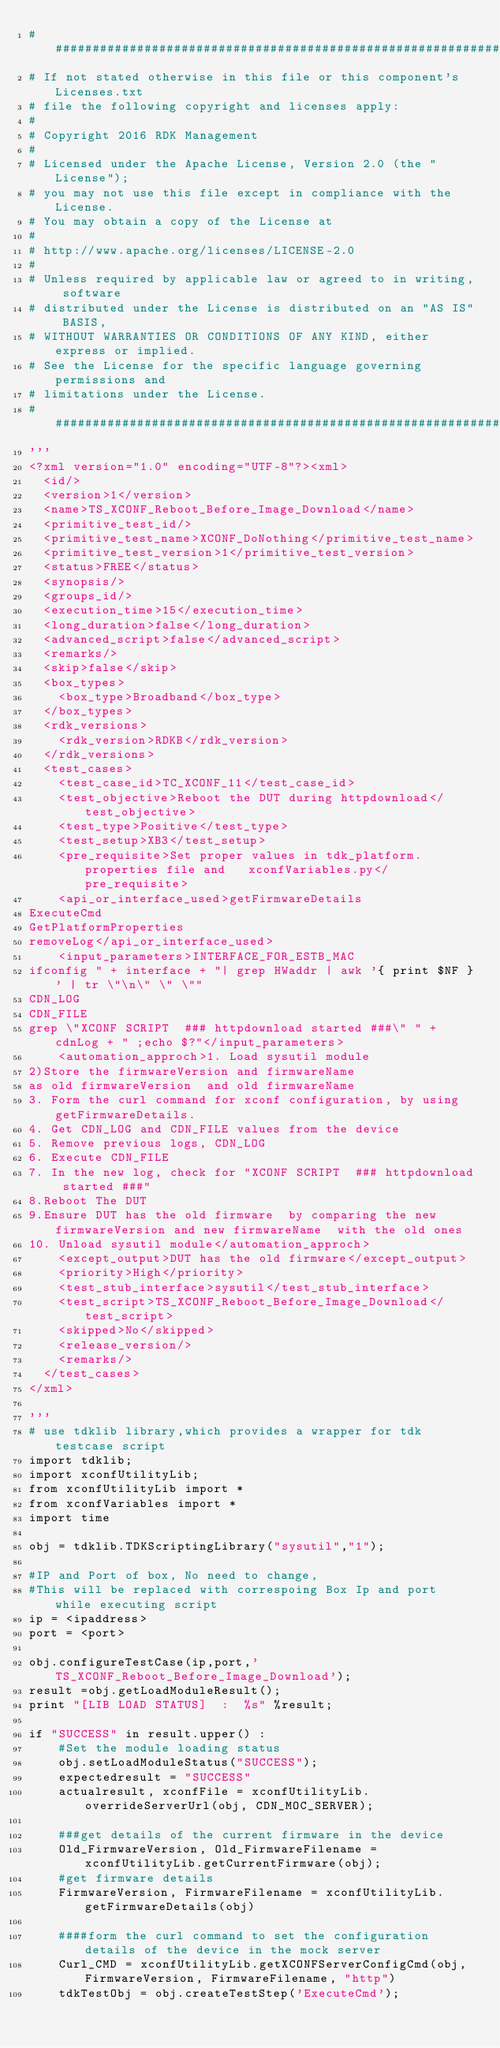Convert code to text. <code><loc_0><loc_0><loc_500><loc_500><_Python_>##########################################################################
# If not stated otherwise in this file or this component's Licenses.txt
# file the following copyright and licenses apply:
#
# Copyright 2016 RDK Management
#
# Licensed under the Apache License, Version 2.0 (the "License");
# you may not use this file except in compliance with the License.
# You may obtain a copy of the License at
#
# http://www.apache.org/licenses/LICENSE-2.0
#
# Unless required by applicable law or agreed to in writing, software
# distributed under the License is distributed on an "AS IS" BASIS,
# WITHOUT WARRANTIES OR CONDITIONS OF ANY KIND, either express or implied.
# See the License for the specific language governing permissions and
# limitations under the License.
##########################################################################
'''
<?xml version="1.0" encoding="UTF-8"?><xml>
  <id/>
  <version>1</version>
  <name>TS_XCONF_Reboot_Before_Image_Download</name>
  <primitive_test_id/>
  <primitive_test_name>XCONF_DoNothing</primitive_test_name>
  <primitive_test_version>1</primitive_test_version>
  <status>FREE</status>
  <synopsis/>
  <groups_id/>
  <execution_time>15</execution_time>
  <long_duration>false</long_duration>
  <advanced_script>false</advanced_script>
  <remarks/>
  <skip>false</skip>
  <box_types>
    <box_type>Broadband</box_type>
  </box_types>
  <rdk_versions>
    <rdk_version>RDKB</rdk_version>
  </rdk_versions>
  <test_cases>
    <test_case_id>TC_XCONF_11</test_case_id>
    <test_objective>Reboot the DUT during httpdownload</test_objective>
    <test_type>Positive</test_type>
    <test_setup>XB3</test_setup>
    <pre_requisite>Set proper values in tdk_platform.properties file and   xconfVariables.py</pre_requisite>
    <api_or_interface_used>getFirmwareDetails
ExecuteCmd
GetPlatformProperties
removeLog</api_or_interface_used>
    <input_parameters>INTERFACE_FOR_ESTB_MAC
ifconfig " + interface + "| grep HWaddr | awk '{ print $NF }' | tr \"\n\" \" \""
CDN_LOG
CDN_FILE
grep \"XCONF SCRIPT  ### httpdownload started ###\" " + cdnLog + " ;echo $?"</input_parameters>
    <automation_approch>1. Load sysutil module
2)Store the firmwareVersion and firmwareName 
as old firmwareVersion  and old firmwareName
3. Form the curl command for xconf configuration, by using getFirmwareDetails.
4. Get CDN_LOG and CDN_FILE values from the device
5. Remove previous logs, CDN_LOG
6. Execute CDN_FILE
7. In the new log, check for "XCONF SCRIPT  ### httpdownload started ###"
8.Reboot The DUT
9.Ensure DUT has the old firmware  by comparing the new firmwareVersion and new firmwareName  with the old ones
10. Unload sysutil module</automation_approch>
    <except_output>DUT has the old firmware</except_output>
    <priority>High</priority>
    <test_stub_interface>sysutil</test_stub_interface>
    <test_script>TS_XCONF_Reboot_Before_Image_Download</test_script>
    <skipped>No</skipped>
    <release_version/>
    <remarks/>
  </test_cases>
</xml>

'''
# use tdklib library,which provides a wrapper for tdk testcase script
import tdklib;
import xconfUtilityLib;
from xconfUtilityLib import *
from xconfVariables import *
import time

obj = tdklib.TDKScriptingLibrary("sysutil","1");

#IP and Port of box, No need to change,
#This will be replaced with correspoing Box Ip and port while executing script
ip = <ipaddress>
port = <port>

obj.configureTestCase(ip,port,'TS_XCONF_Reboot_Before_Image_Download');
result =obj.getLoadModuleResult();
print "[LIB LOAD STATUS]  :  %s" %result;

if "SUCCESS" in result.upper() :
    #Set the module loading status
    obj.setLoadModuleStatus("SUCCESS");
    expectedresult = "SUCCESS"
    actualresult, xconfFile = xconfUtilityLib.overrideServerUrl(obj, CDN_MOC_SERVER);

    ###get details of the current firmware in the device
    Old_FirmwareVersion, Old_FirmwareFilename = xconfUtilityLib.getCurrentFirmware(obj);
    #get firmware details
    FirmwareVersion, FirmwareFilename = xconfUtilityLib.getFirmwareDetails(obj)

    ####form the curl command to set the configuration details of the device in the mock server
    Curl_CMD = xconfUtilityLib.getXCONFServerConfigCmd(obj, FirmwareVersion, FirmwareFilename, "http")
    tdkTestObj = obj.createTestStep('ExecuteCmd');</code> 